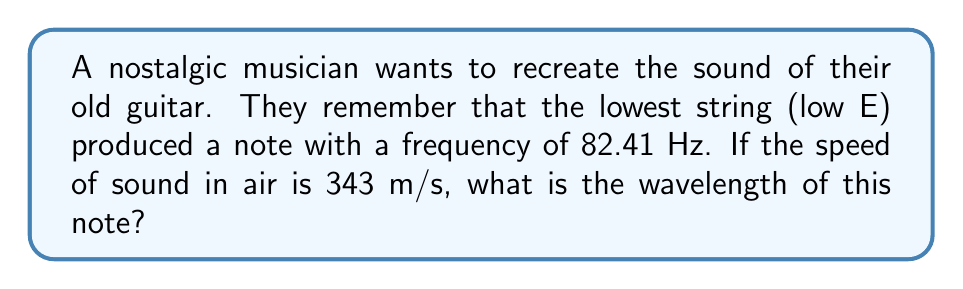Can you answer this question? To solve this problem, we'll use the relationship between frequency, wavelength, and the speed of sound. The equation that relates these variables is:

$$ v = f \lambda $$

Where:
$v$ is the speed of sound in m/s
$f$ is the frequency in Hz
$\lambda$ is the wavelength in m

We're given:
$v = 343$ m/s
$f = 82.41$ Hz

To find the wavelength, we rearrange the equation to solve for $\lambda$:

$$ \lambda = \frac{v}{f} $$

Now we can substitute the known values:

$$ \lambda = \frac{343 \text{ m/s}}{82.41 \text{ Hz}} $$

Calculating this:

$$ \lambda = 4.16 \text{ m} $$

To get a more precise answer, we can carry out the division to more decimal places:

$$ \lambda = 4.1622378349709986 \text{ m} $$

Rounding to two decimal places for a practical answer:

$$ \lambda \approx 4.16 \text{ m} $$

This means that the wavelength of the low E string on the guitar is approximately 4.16 meters.
Answer: The wavelength of the low E string (82.41 Hz) is approximately 4.16 m. 